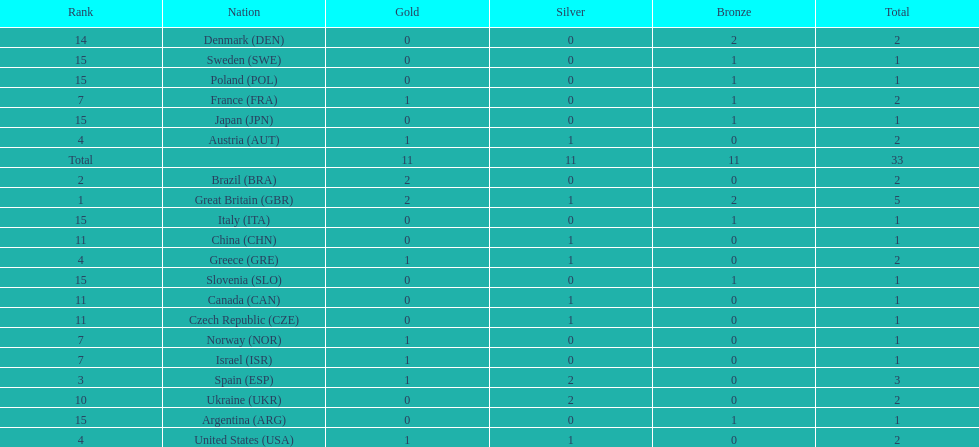How many gold medals did italy receive? 0. 